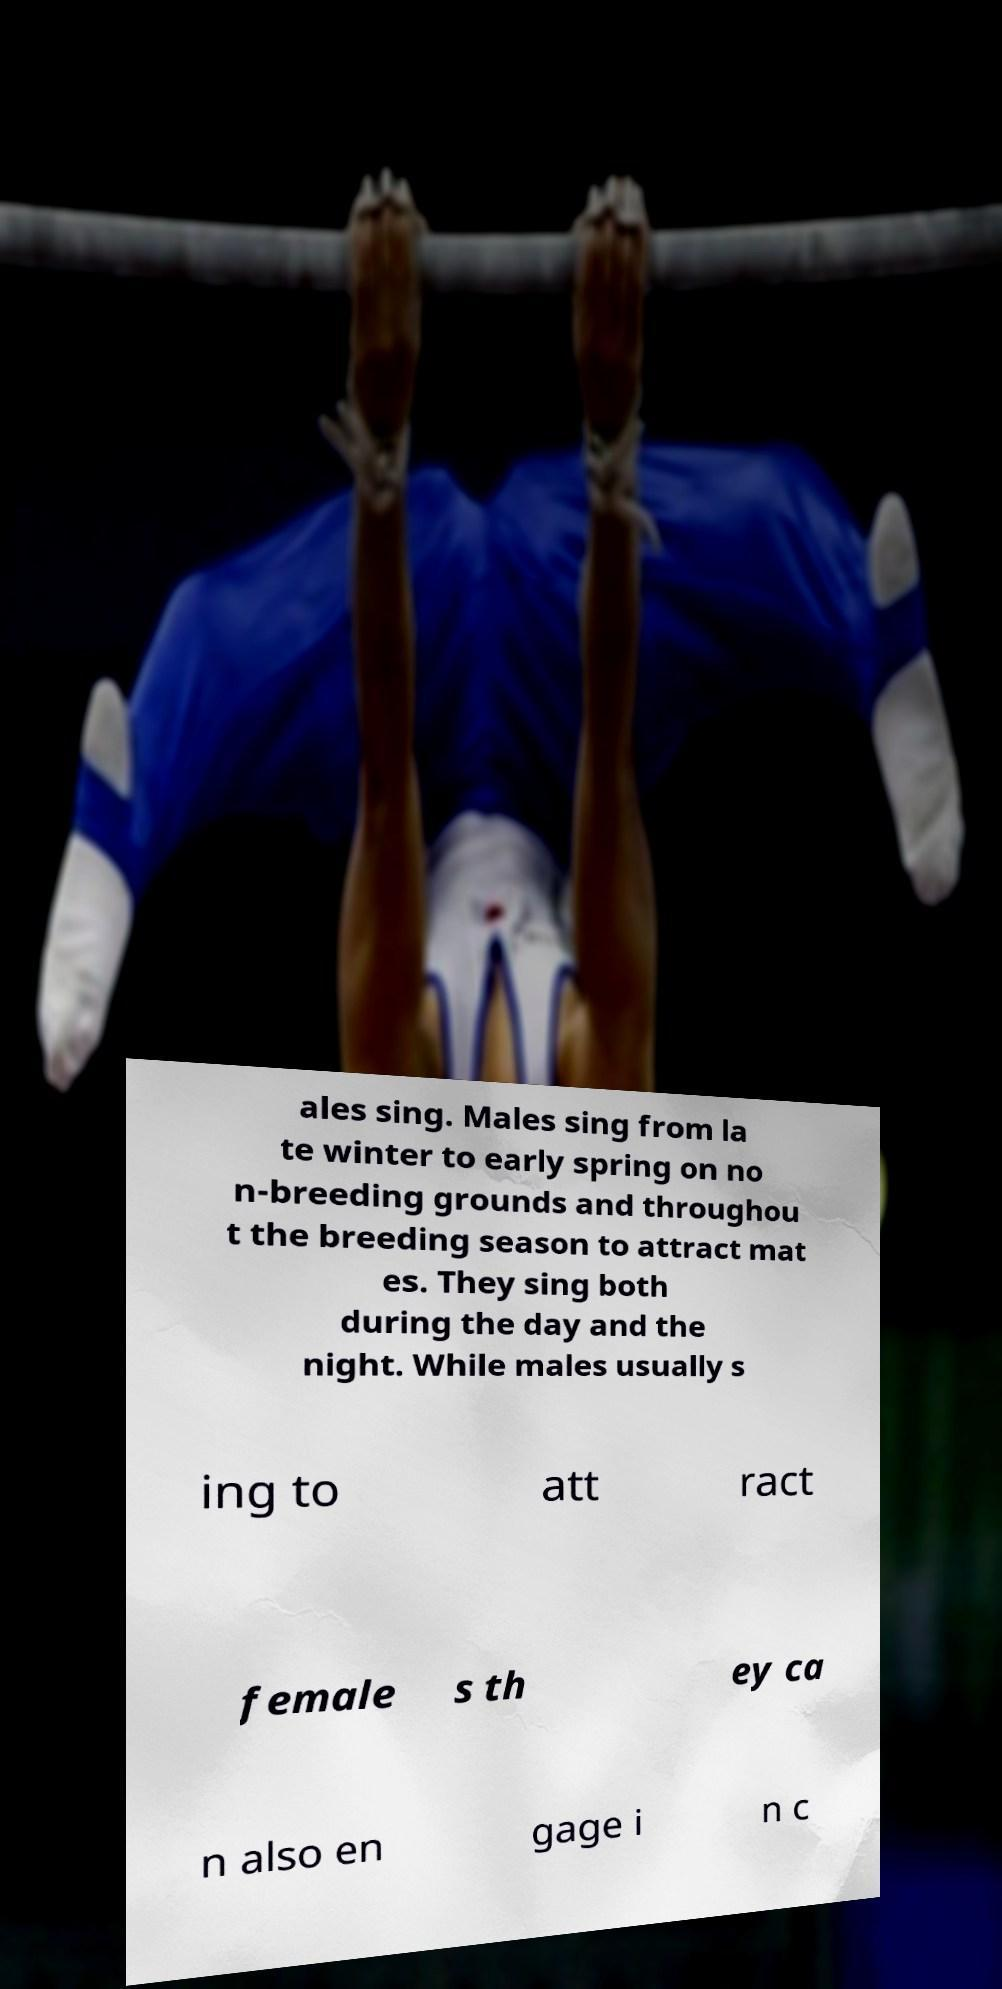For documentation purposes, I need the text within this image transcribed. Could you provide that? ales sing. Males sing from la te winter to early spring on no n-breeding grounds and throughou t the breeding season to attract mat es. They sing both during the day and the night. While males usually s ing to att ract female s th ey ca n also en gage i n c 